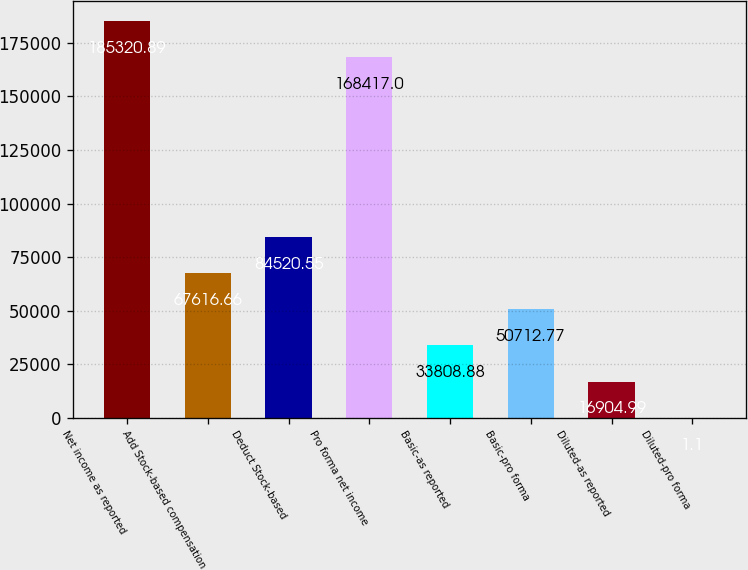<chart> <loc_0><loc_0><loc_500><loc_500><bar_chart><fcel>Net income as reported<fcel>Add Stock-based compensation<fcel>Deduct Stock-based<fcel>Pro forma net income<fcel>Basic-as reported<fcel>Basic-pro forma<fcel>Diluted-as reported<fcel>Diluted-pro forma<nl><fcel>185321<fcel>67616.7<fcel>84520.6<fcel>168417<fcel>33808.9<fcel>50712.8<fcel>16905<fcel>1.1<nl></chart> 